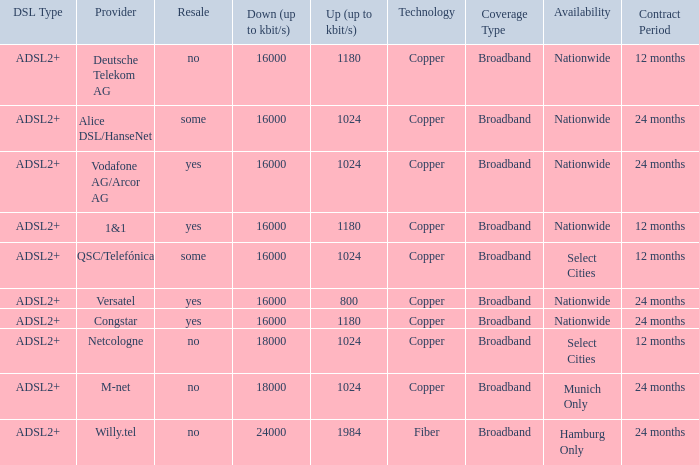Could you help me parse every detail presented in this table? {'header': ['DSL Type', 'Provider', 'Resale', 'Down (up to kbit/s)', 'Up (up to kbit/s)', 'Technology', 'Coverage Type', 'Availability', 'Contract Period'], 'rows': [['ADSL2+', 'Deutsche Telekom AG', 'no', '16000', '1180', 'Copper', 'Broadband', 'Nationwide', '12 months'], ['ADSL2+', 'Alice DSL/HanseNet', 'some', '16000', '1024', 'Copper', 'Broadband', 'Nationwide', '24 months'], ['ADSL2+', 'Vodafone AG/Arcor AG', 'yes', '16000', '1024', 'Copper', 'Broadband', 'Nationwide', '24 months'], ['ADSL2+', '1&1', 'yes', '16000', '1180', 'Copper', 'Broadband', 'Nationwide', '12 months'], ['ADSL2+', 'QSC/Telefónica', 'some', '16000', '1024', 'Copper', 'Broadband', 'Select Cities', '12 months'], ['ADSL2+', 'Versatel', 'yes', '16000', '800', 'Copper', 'Broadband', 'Nationwide', '24 months'], ['ADSL2+', 'Congstar', 'yes', '16000', '1180', 'Copper', 'Broadband', 'Nationwide', '24 months'], ['ADSL2+', 'Netcologne', 'no', '18000', '1024', 'Copper', 'Broadband', 'Select Cities', '12 months'], ['ADSL2+', 'M-net', 'no', '18000', '1024', 'Copper', 'Broadband', 'Munich Only', '24 months'], ['ADSL2+', 'Willy.tel', 'no', '24000', '1984', 'Fiber', 'Broadband', 'Hamburg Only', '24 months']]} Who are all of the telecom providers for which the upload rate is 1024 kbits and the resale category is yes? Vodafone AG/Arcor AG. 